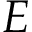Convert formula to latex. <formula><loc_0><loc_0><loc_500><loc_500>E</formula> 